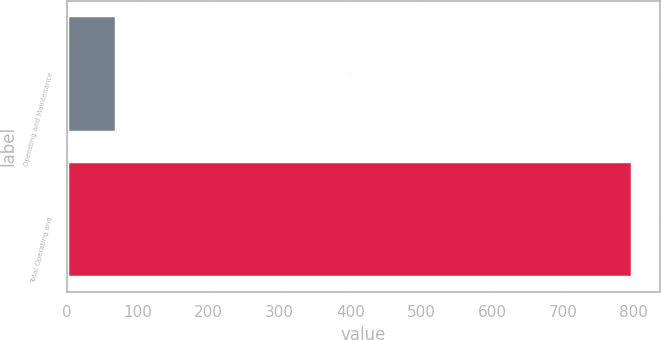Convert chart. <chart><loc_0><loc_0><loc_500><loc_500><bar_chart><fcel>Operating and Maintenance<fcel>Total Operating and<nl><fcel>69<fcel>797.5<nl></chart> 